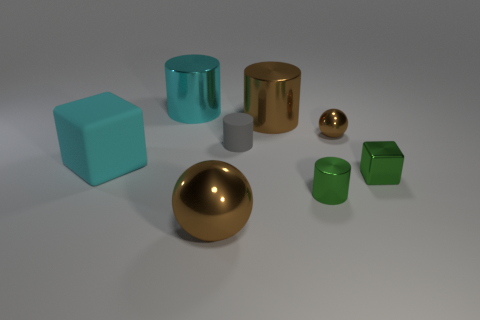What number of shiny things are either large cyan objects or small green objects?
Offer a terse response. 3. Is the gray cylinder that is to the right of the cyan cylinder made of the same material as the large brown object that is in front of the tiny green metal cylinder?
Keep it short and to the point. No. What is the color of the big sphere that is the same material as the tiny green cylinder?
Offer a very short reply. Brown. Is the number of green metal cubes that are behind the small ball greater than the number of small green shiny blocks in front of the small gray object?
Your response must be concise. No. Are there any small brown shiny balls?
Provide a succinct answer. Yes. There is a big object that is the same color as the big cube; what is it made of?
Your response must be concise. Metal. How many things are big cylinders or small cubes?
Provide a succinct answer. 3. Is there a thing that has the same color as the small shiny cube?
Your answer should be very brief. Yes. What number of brown metal spheres are to the left of the large thing in front of the large matte object?
Ensure brevity in your answer.  0. Is the number of gray metal things greater than the number of green metallic blocks?
Provide a short and direct response. No. 